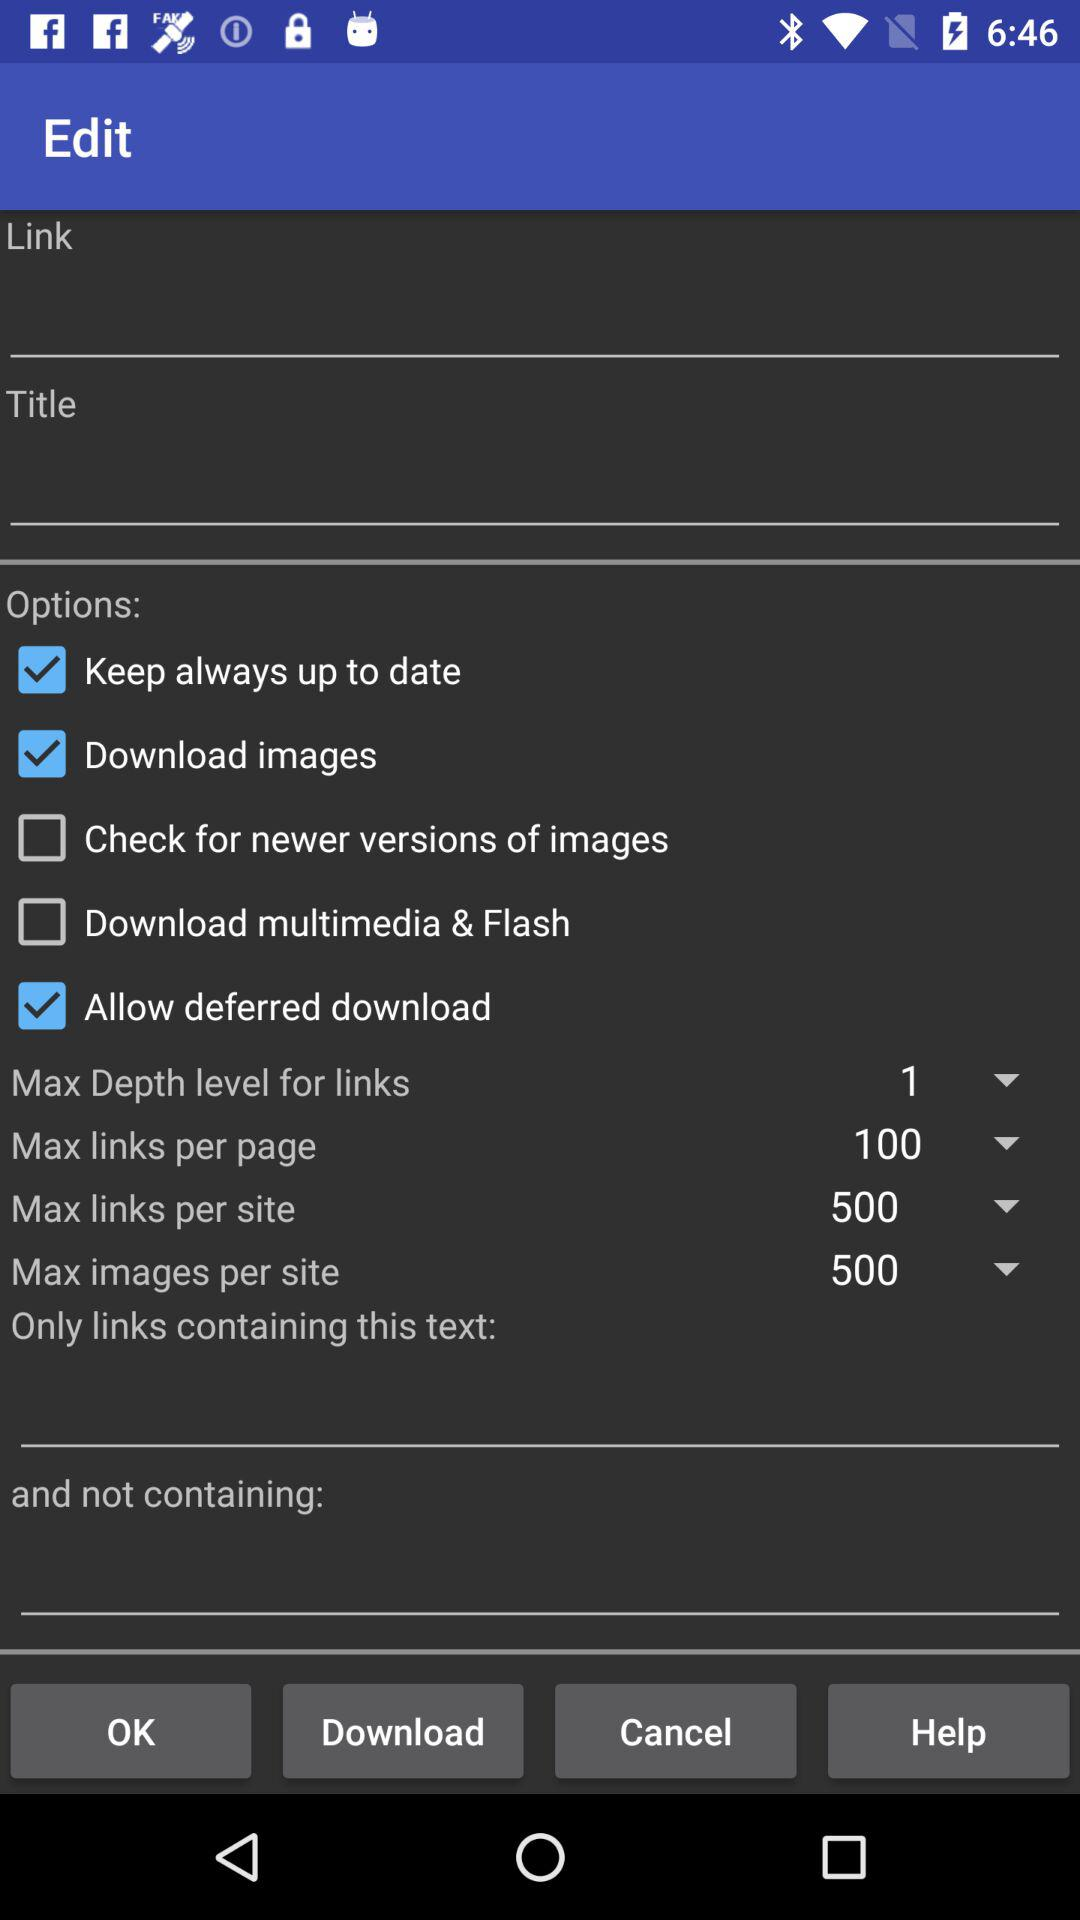What is the maximum number of links per site? The maximum number of links per site is 500. 